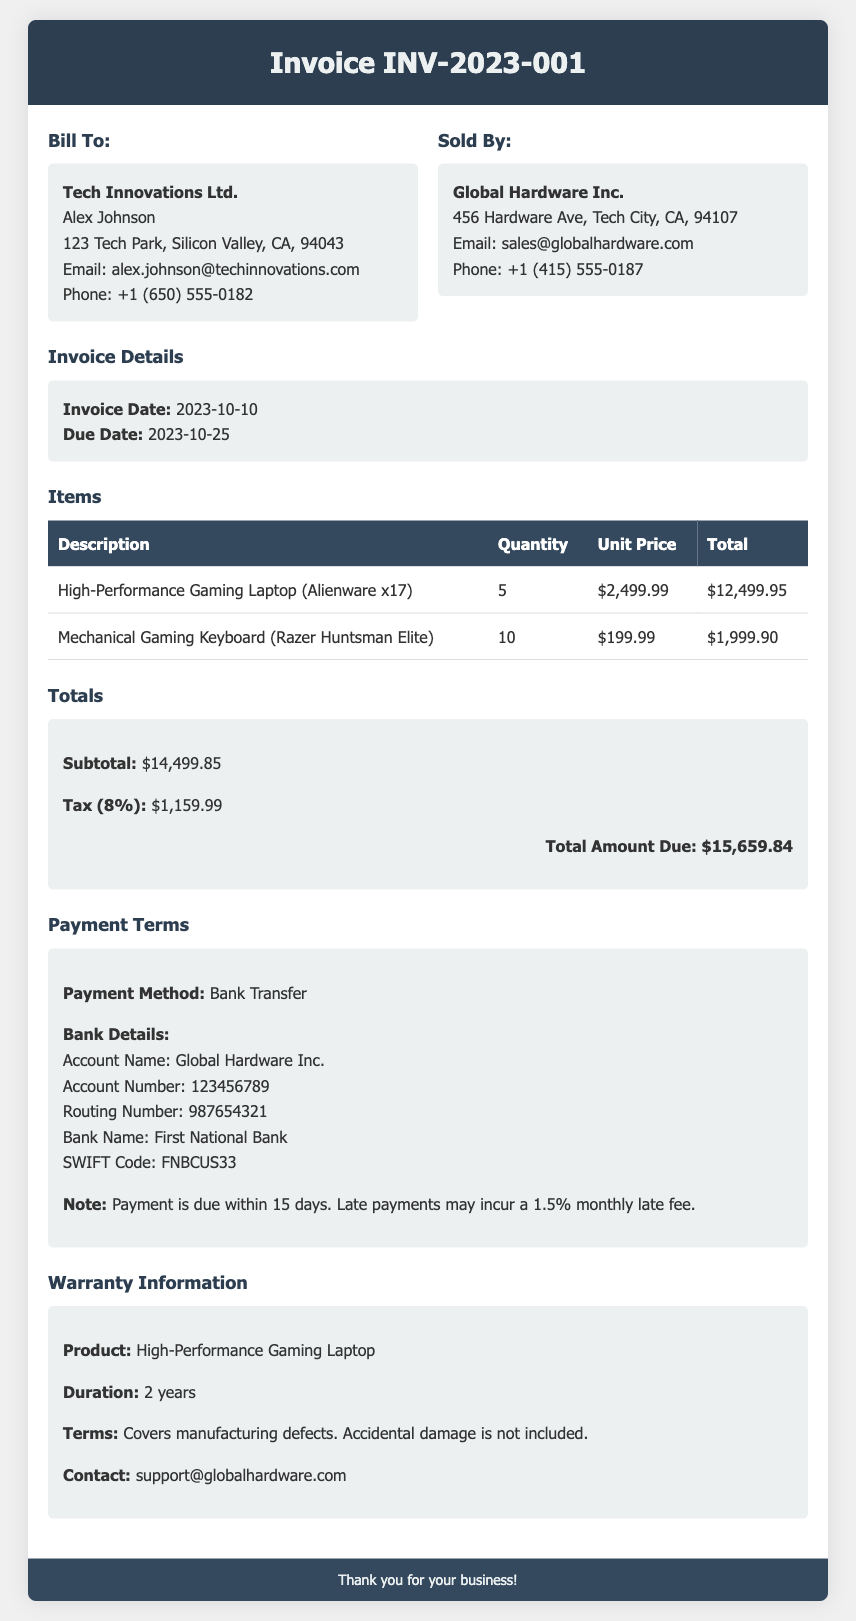What is the invoice number? The invoice number is explicitly stated in the header of the document.
Answer: INV-2023-001 Who is the bill recipient? The recipient's information can be found under the "Bill To" section.
Answer: Tech Innovations Ltd What is the total amount due? The total amount due is highlighted in the "Totals" section of the document.
Answer: $15,659.84 What is the warranty duration for the gaming laptop? The warranty duration is found in the "Warranty Information" section.
Answer: 2 years What is the payment due date? The payment due date is mentioned under "Invoice Details."
Answer: 2023-10-25 How many mechanical gaming keyboards are ordered? The quantity ordered is listed in the "Items" table.
Answer: 10 What is the bank name for the payment? The bank name can be found in the "Payment Terms" section.
Answer: First National Bank What is the late fee percentage stated in the invoice? The late fee percentage is provided in the "Payment Terms" section and refers to late payments.
Answer: 1.5% 